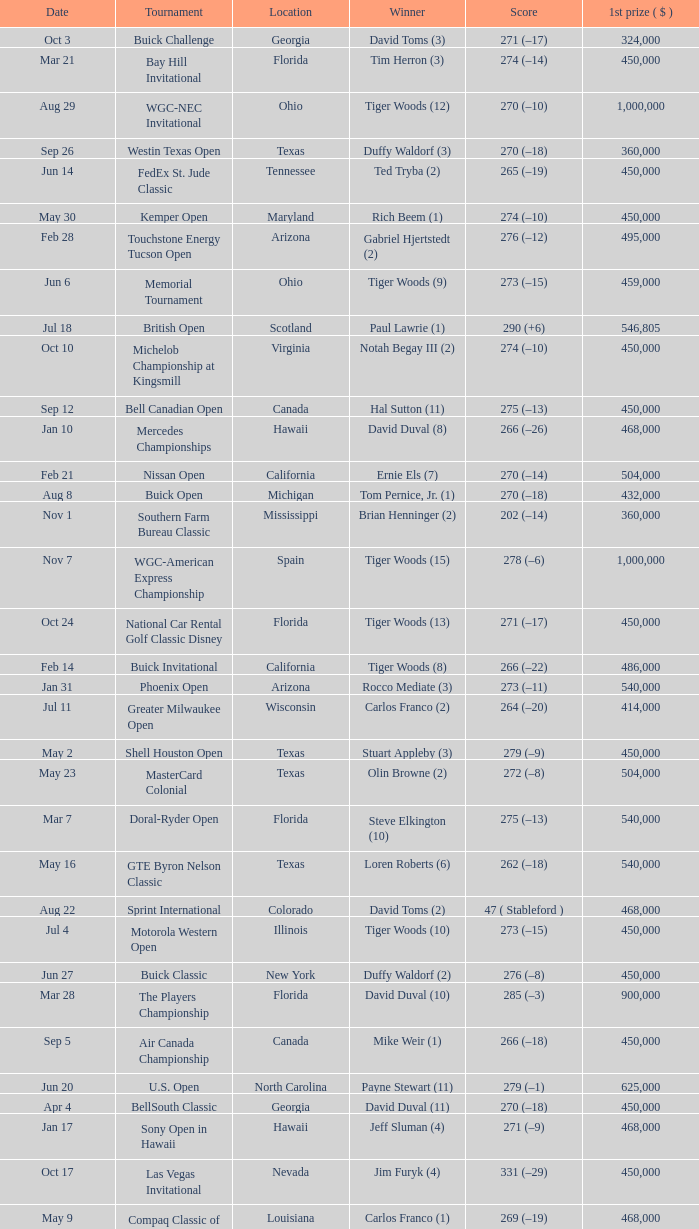Help me parse the entirety of this table. {'header': ['Date', 'Tournament', 'Location', 'Winner', 'Score', '1st prize ( $ )'], 'rows': [['Oct 3', 'Buick Challenge', 'Georgia', 'David Toms (3)', '271 (–17)', '324,000'], ['Mar 21', 'Bay Hill Invitational', 'Florida', 'Tim Herron (3)', '274 (–14)', '450,000'], ['Aug 29', 'WGC-NEC Invitational', 'Ohio', 'Tiger Woods (12)', '270 (–10)', '1,000,000'], ['Sep 26', 'Westin Texas Open', 'Texas', 'Duffy Waldorf (3)', '270 (–18)', '360,000'], ['Jun 14', 'FedEx St. Jude Classic', 'Tennessee', 'Ted Tryba (2)', '265 (–19)', '450,000'], ['May 30', 'Kemper Open', 'Maryland', 'Rich Beem (1)', '274 (–10)', '450,000'], ['Feb 28', 'Touchstone Energy Tucson Open', 'Arizona', 'Gabriel Hjertstedt (2)', '276 (–12)', '495,000'], ['Jun 6', 'Memorial Tournament', 'Ohio', 'Tiger Woods (9)', '273 (–15)', '459,000'], ['Jul 18', 'British Open', 'Scotland', 'Paul Lawrie (1)', '290 (+6)', '546,805'], ['Oct 10', 'Michelob Championship at Kingsmill', 'Virginia', 'Notah Begay III (2)', '274 (–10)', '450,000'], ['Sep 12', 'Bell Canadian Open', 'Canada', 'Hal Sutton (11)', '275 (–13)', '450,000'], ['Jan 10', 'Mercedes Championships', 'Hawaii', 'David Duval (8)', '266 (–26)', '468,000'], ['Feb 21', 'Nissan Open', 'California', 'Ernie Els (7)', '270 (–14)', '504,000'], ['Aug 8', 'Buick Open', 'Michigan', 'Tom Pernice, Jr. (1)', '270 (–18)', '432,000'], ['Nov 1', 'Southern Farm Bureau Classic', 'Mississippi', 'Brian Henninger (2)', '202 (–14)', '360,000'], ['Nov 7', 'WGC-American Express Championship', 'Spain', 'Tiger Woods (15)', '278 (–6)', '1,000,000'], ['Oct 24', 'National Car Rental Golf Classic Disney', 'Florida', 'Tiger Woods (13)', '271 (–17)', '450,000'], ['Feb 14', 'Buick Invitational', 'California', 'Tiger Woods (8)', '266 (–22)', '486,000'], ['Jan 31', 'Phoenix Open', 'Arizona', 'Rocco Mediate (3)', '273 (–11)', '540,000'], ['Jul 11', 'Greater Milwaukee Open', 'Wisconsin', 'Carlos Franco (2)', '264 (–20)', '414,000'], ['May 2', 'Shell Houston Open', 'Texas', 'Stuart Appleby (3)', '279 (–9)', '450,000'], ['May 23', 'MasterCard Colonial', 'Texas', 'Olin Browne (2)', '272 (–8)', '504,000'], ['Mar 7', 'Doral-Ryder Open', 'Florida', 'Steve Elkington (10)', '275 (–13)', '540,000'], ['May 16', 'GTE Byron Nelson Classic', 'Texas', 'Loren Roberts (6)', '262 (–18)', '540,000'], ['Aug 22', 'Sprint International', 'Colorado', 'David Toms (2)', '47 ( Stableford )', '468,000'], ['Jul 4', 'Motorola Western Open', 'Illinois', 'Tiger Woods (10)', '273 (–15)', '450,000'], ['Jun 27', 'Buick Classic', 'New York', 'Duffy Waldorf (2)', '276 (–8)', '450,000'], ['Mar 28', 'The Players Championship', 'Florida', 'David Duval (10)', '285 (–3)', '900,000'], ['Sep 5', 'Air Canada Championship', 'Canada', 'Mike Weir (1)', '266 (–18)', '450,000'], ['Jun 20', 'U.S. Open', 'North Carolina', 'Payne Stewart (11)', '279 (–1)', '625,000'], ['Apr 4', 'BellSouth Classic', 'Georgia', 'David Duval (11)', '270 (–18)', '450,000'], ['Jan 17', 'Sony Open in Hawaii', 'Hawaii', 'Jeff Sluman (4)', '271 (–9)', '468,000'], ['Oct 17', 'Las Vegas Invitational', 'Nevada', 'Jim Furyk (4)', '331 (–29)', '450,000'], ['May 9', 'Compaq Classic of New Orleans', 'Louisiana', 'Carlos Franco (1)', '269 (–19)', '468,000'], ['Apr 25', 'Greater Greensboro Chrysler Classic', 'North Carolina', 'Jesper Parnevik (2)', '265 (–23)', '468,000'], ['Jul 25', 'John Deere Classic', 'Illinois', 'J. L. Lewis (1)', '261 (–19)', '360,000'], ['Apr 11', 'Masters Tournament', 'Georgia', 'José María Olazábal (5)', '280 (–8)', '720,000'], ['Feb 7', 'AT&T Pebble Beach National Pro-Am', 'California', 'Payne Stewart (10)', '206 (–10)', '504,000'], ['Aug 29', 'Reno-Tahoe Open', 'Nevada', 'Notah Begay III (1)', '274 (–14)', '495,000'], ['Sep 19', 'B.C. Open', 'New York', 'Brad Faxon (5)', '273 (–15)', '288,000'], ['Oct 31', 'The Tour Championship', 'Texas', 'Tiger Woods (14)', '269 (–15)', '900,000'], ['Apr 18', 'MCI Classic', 'South Carolina', 'Glen Day (1)', '274 (–10)', '450,000'], ['Aug 1', 'Canon Greater Hartford Open', 'Connecticut', 'Brent Geiberger (1)', '262 (–18)', '450,000'], ['Mar 14', 'Honda Classic', 'Florida', 'Vijay Singh (8)', '277 (–11)', '468,000'], ['Feb 28', 'WGC-Andersen Consulting Match Play Championship', 'California', 'Jeff Maggert (2)', '38 holes', '1,000,000'], ['Jan 24', 'Bob Hope Chrysler Classic', 'California', 'David Duval (9)', '334 (–26)', '540,000'], ['Aug 15', 'PGA Championship', 'Illinois', 'Tiger Woods (11)', '277 (–11)', '630,000']]} What is the date of the Greater Greensboro Chrysler Classic? Apr 25. 